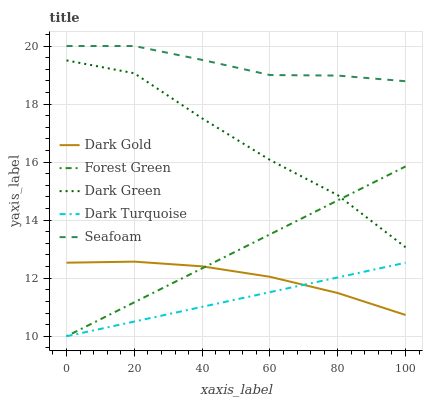Does Dark Turquoise have the minimum area under the curve?
Answer yes or no. Yes. Does Seafoam have the maximum area under the curve?
Answer yes or no. Yes. Does Forest Green have the minimum area under the curve?
Answer yes or no. No. Does Forest Green have the maximum area under the curve?
Answer yes or no. No. Is Dark Turquoise the smoothest?
Answer yes or no. Yes. Is Dark Green the roughest?
Answer yes or no. Yes. Is Forest Green the smoothest?
Answer yes or no. No. Is Forest Green the roughest?
Answer yes or no. No. Does Dark Green have the lowest value?
Answer yes or no. No. Does Forest Green have the highest value?
Answer yes or no. No. Is Dark Turquoise less than Seafoam?
Answer yes or no. Yes. Is Seafoam greater than Dark Gold?
Answer yes or no. Yes. Does Dark Turquoise intersect Seafoam?
Answer yes or no. No. 